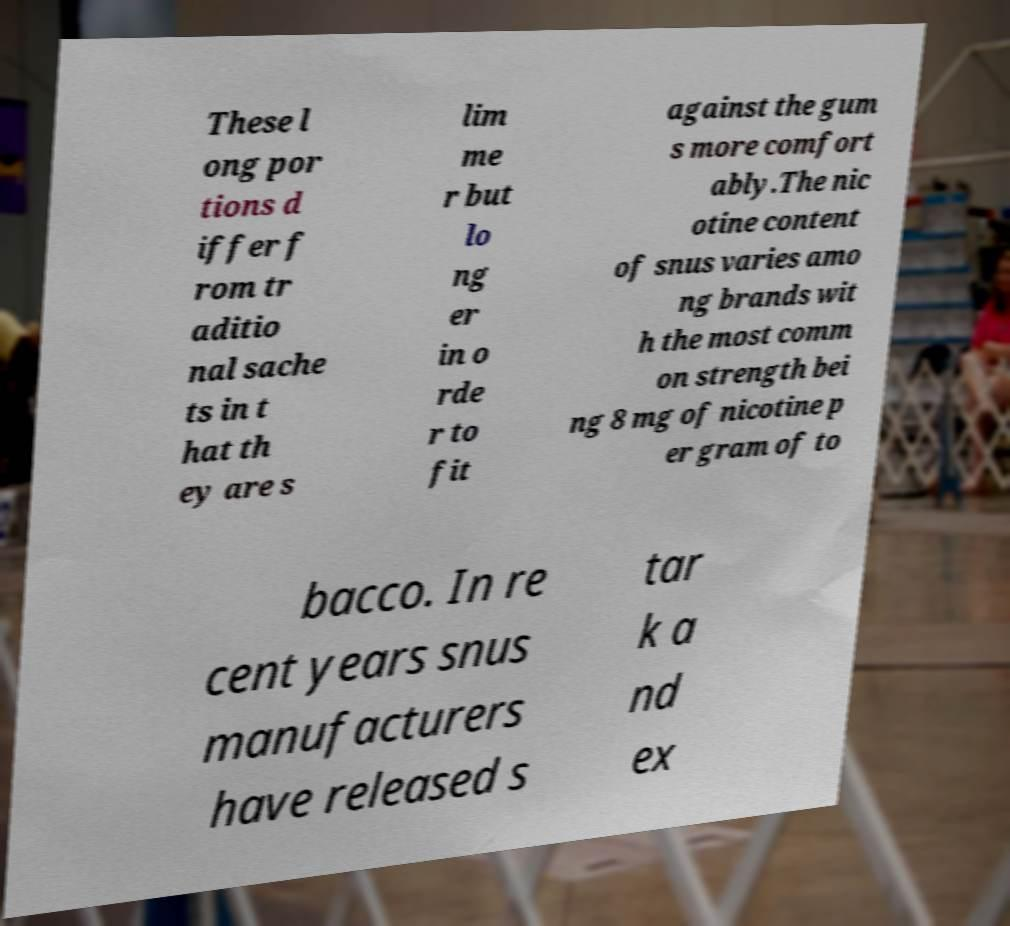Can you accurately transcribe the text from the provided image for me? These l ong por tions d iffer f rom tr aditio nal sache ts in t hat th ey are s lim me r but lo ng er in o rde r to fit against the gum s more comfort ably.The nic otine content of snus varies amo ng brands wit h the most comm on strength bei ng 8 mg of nicotine p er gram of to bacco. In re cent years snus manufacturers have released s tar k a nd ex 